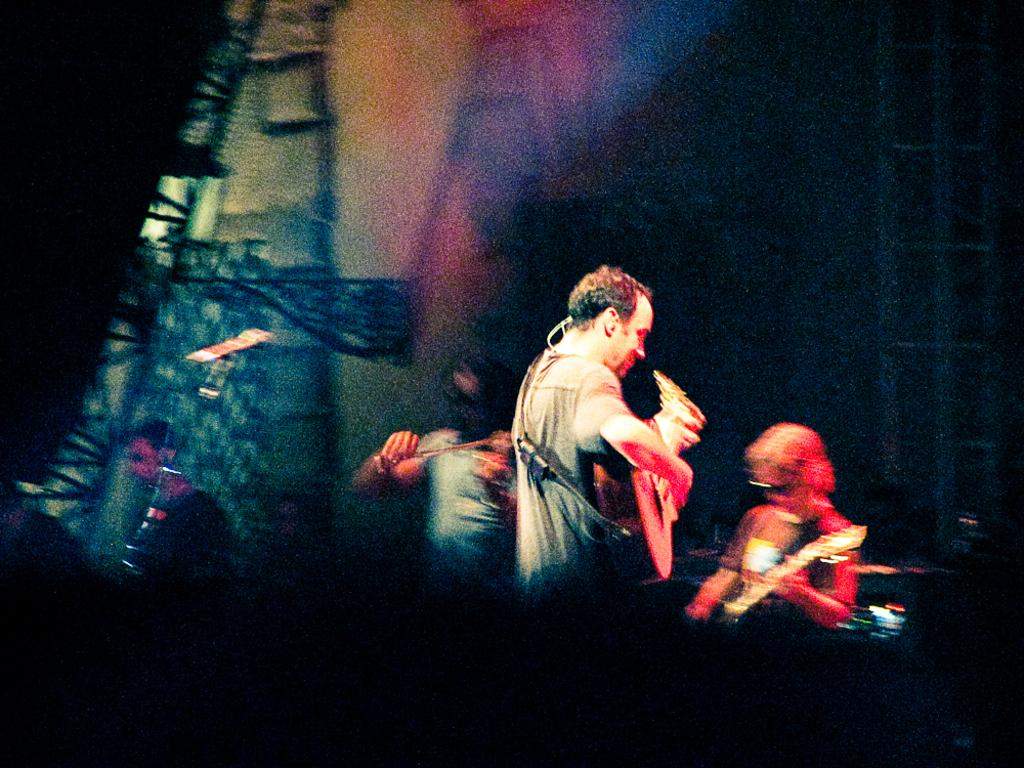How many people are in the image? There are people in the image, but the exact number is not specified. What are the people doing in the image? The people in the image are holding musical instruments. What type of knife is being used in the religious ceremony depicted in the image? There is no knife or religious ceremony present in the image; it features people holding musical instruments. What type of club is the person holding in the image? There is no club present in the image; it features people holding musical instruments. 